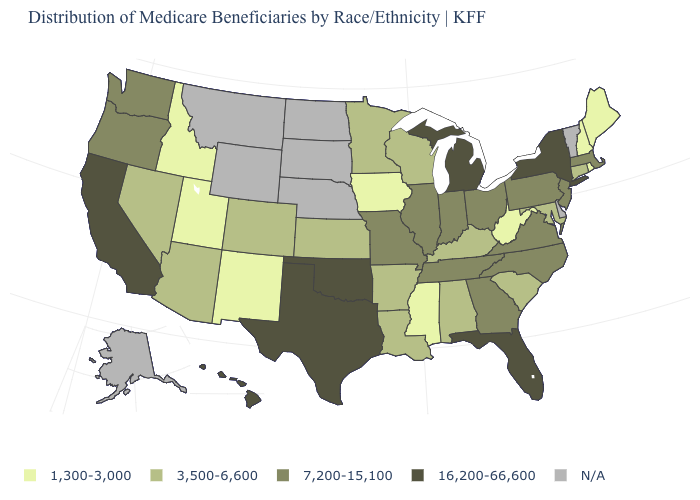Does California have the highest value in the West?
Short answer required. Yes. What is the lowest value in the USA?
Concise answer only. 1,300-3,000. What is the value of Connecticut?
Write a very short answer. 3,500-6,600. What is the value of New York?
Give a very brief answer. 16,200-66,600. Among the states that border Florida , which have the highest value?
Short answer required. Georgia. What is the value of North Dakota?
Write a very short answer. N/A. What is the value of New York?
Answer briefly. 16,200-66,600. What is the value of Wisconsin?
Write a very short answer. 3,500-6,600. Does Michigan have the highest value in the MidWest?
Concise answer only. Yes. What is the lowest value in the USA?
Quick response, please. 1,300-3,000. What is the value of Maine?
Quick response, please. 1,300-3,000. What is the value of Arizona?
Be succinct. 3,500-6,600. What is the value of Kentucky?
Quick response, please. 3,500-6,600. Among the states that border Iowa , which have the lowest value?
Quick response, please. Minnesota, Wisconsin. What is the lowest value in the USA?
Short answer required. 1,300-3,000. 